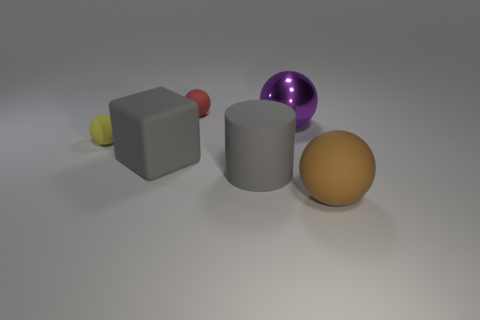What number of other objects are the same material as the big brown sphere?
Provide a short and direct response. 4. Are there more large metallic objects than blue rubber spheres?
Ensure brevity in your answer.  Yes. There is a tiny matte sphere on the right side of the yellow rubber thing; does it have the same color as the rubber cylinder?
Your response must be concise. No. What color is the metallic sphere?
Your response must be concise. Purple. There is a small rubber ball that is in front of the small red ball; is there a red ball that is behind it?
Your response must be concise. Yes. There is a rubber thing behind the large sphere that is left of the big brown thing; what shape is it?
Provide a short and direct response. Sphere. Are there fewer tiny purple things than yellow things?
Your answer should be compact. Yes. Do the big brown ball and the large gray cylinder have the same material?
Provide a succinct answer. Yes. There is a sphere that is in front of the large purple shiny thing and on the left side of the big gray matte cylinder; what is its color?
Make the answer very short. Yellow. Is there a blue rubber block of the same size as the rubber cylinder?
Offer a very short reply. No. 